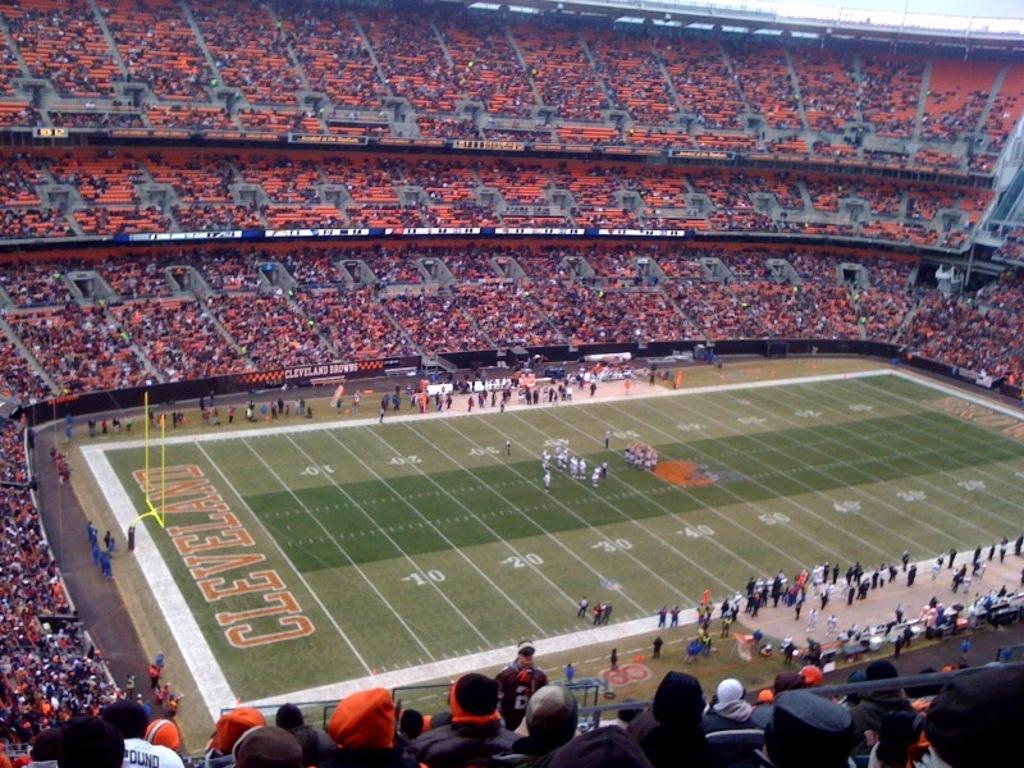<image>
Offer a succinct explanation of the picture presented. The Cleveland End Zone as seen from the top of the stadium stands during a game. 